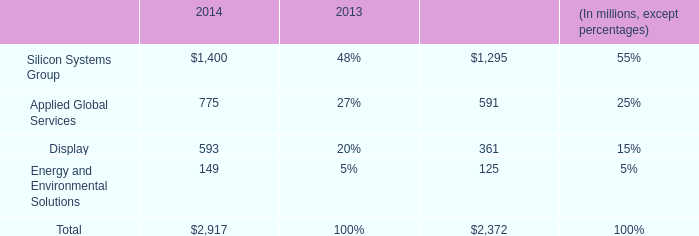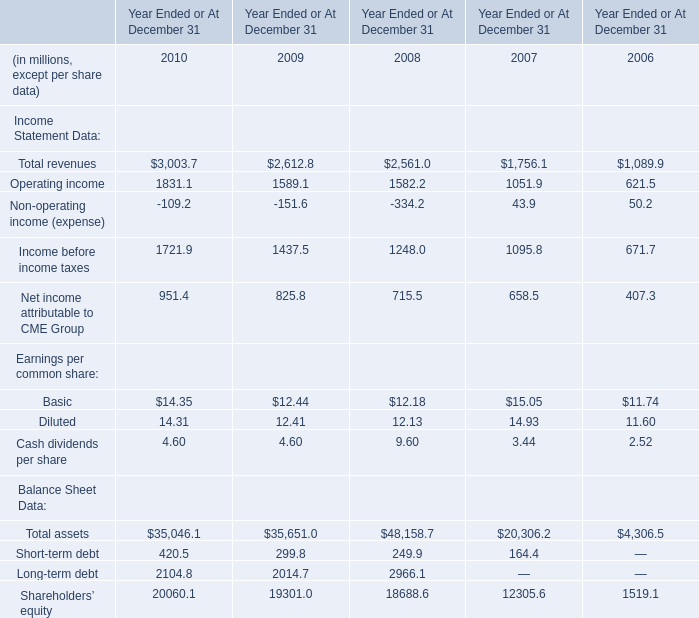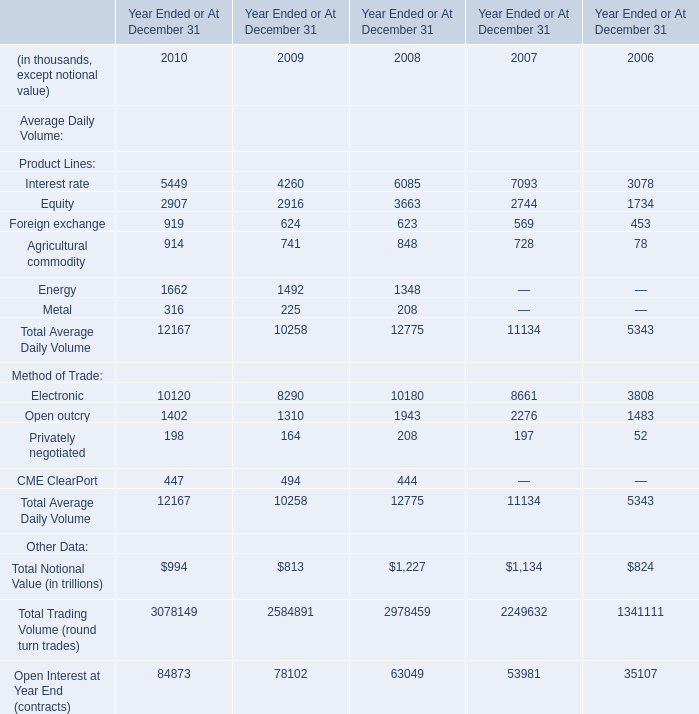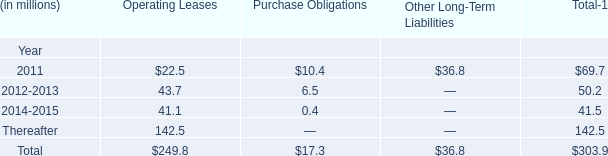What is the sum of the Total revenues in the years / sections where Operating income is positive? (in millions) 
Computations: ((((3003.7 + 2612.8) + 2561.0) + 1756.1) + 1089.9)
Answer: 11023.5. 